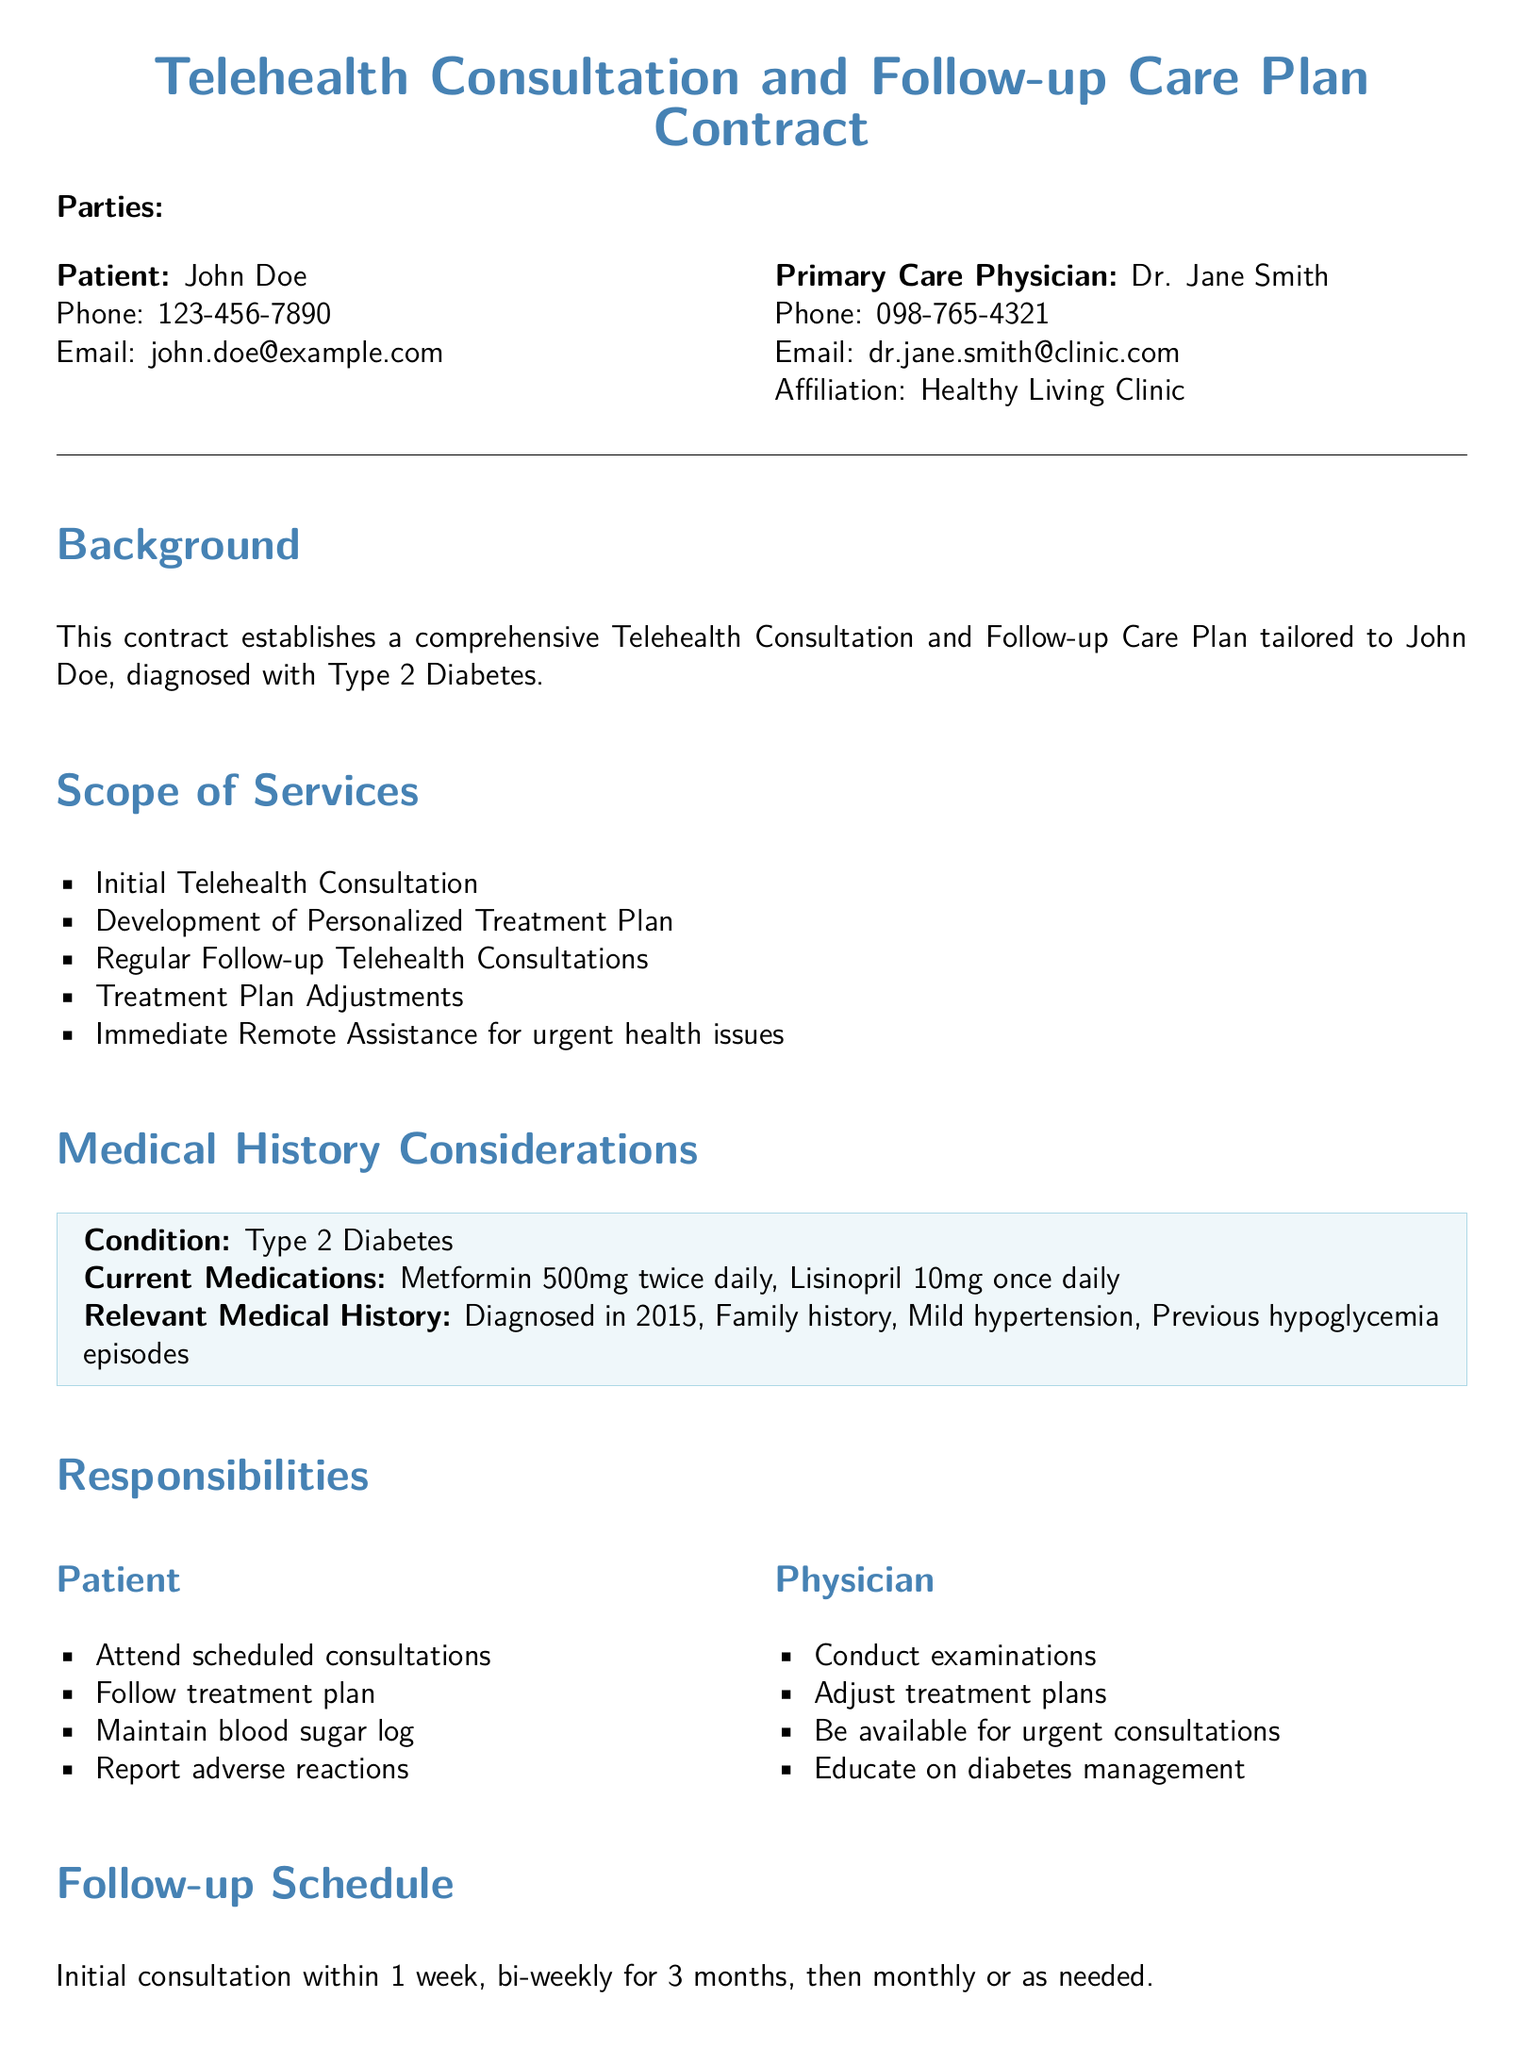what is the patient's name? The patient's name is stated at the beginning of the document as John Doe.
Answer: John Doe what is the physician's email? The physician's email is provided in the contact information section of the document.
Answer: dr.jane.smith@clinic.com how many medications is the patient currently taking? The document lists the current medications of the patient which totals two.
Answer: 2 what condition is the patient diagnosed with? The condition diagnosed is mentioned in the Background section of the document.
Answer: Type 2 Diabetes what is the initial consultation timeframe? The document specifies the initial consultation should occur within a certain period.
Answer: 1 week who is responsible for maintaining a blood sugar log? The list of responsibilities outlines specific tasks for the patient, including this task.
Answer: Patient what does the physician need to do when conducting examinations? The responsibilities include adjusting treatment plans after conducting examinations.
Answer: Adjust treatment plans what is the duration of the contract? The duration of the contract is explicitly mentioned in the Duration and Termination section.
Answer: 1 year what is required for contract termination? The termination process is detailed in the relevant section of the document, highlighting the need for notification.
Answer: 30-day notice 